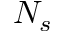Convert formula to latex. <formula><loc_0><loc_0><loc_500><loc_500>N _ { s }</formula> 